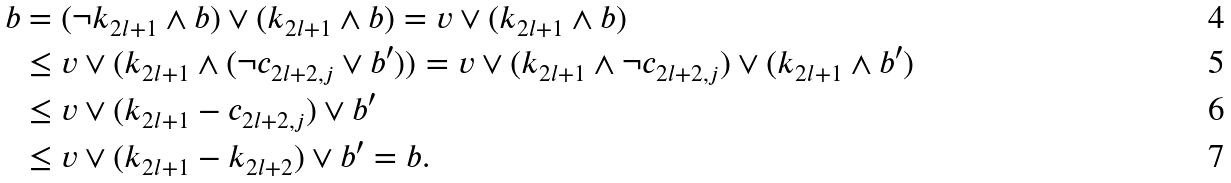<formula> <loc_0><loc_0><loc_500><loc_500>b & = ( \neg k _ { 2 l + 1 } \wedge b ) \vee ( k _ { 2 l + 1 } \wedge b ) = v \vee ( k _ { 2 l + 1 } \wedge b ) \\ & \leq v \vee ( k _ { 2 l + 1 } \wedge ( \neg c _ { 2 l + 2 , j } \vee b ^ { \prime } ) ) = v \vee ( k _ { 2 l + 1 } \wedge \neg c _ { 2 l + 2 , j } ) \vee ( k _ { 2 l + 1 } \wedge b ^ { \prime } ) \\ & \leq v \vee ( k _ { 2 l + 1 } - c _ { 2 l + 2 , j } ) \vee b ^ { \prime } \\ & \leq v \vee ( k _ { 2 l + 1 } - k _ { 2 l + 2 } ) \vee b ^ { \prime } = b .</formula> 